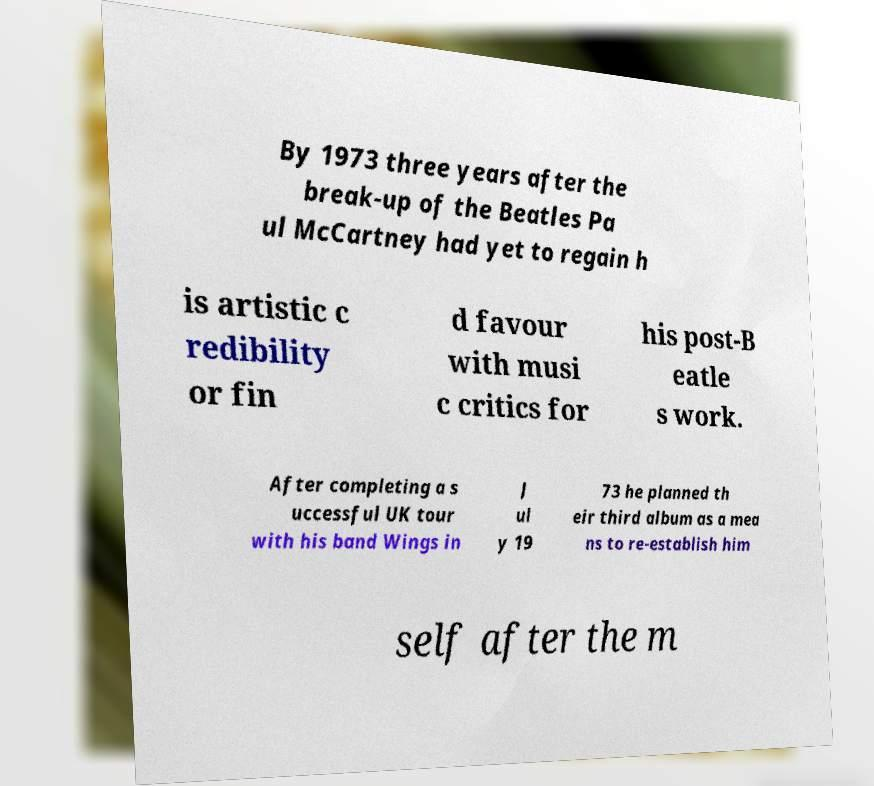What messages or text are displayed in this image? I need them in a readable, typed format. By 1973 three years after the break-up of the Beatles Pa ul McCartney had yet to regain h is artistic c redibility or fin d favour with musi c critics for his post-B eatle s work. After completing a s uccessful UK tour with his band Wings in J ul y 19 73 he planned th eir third album as a mea ns to re-establish him self after the m 